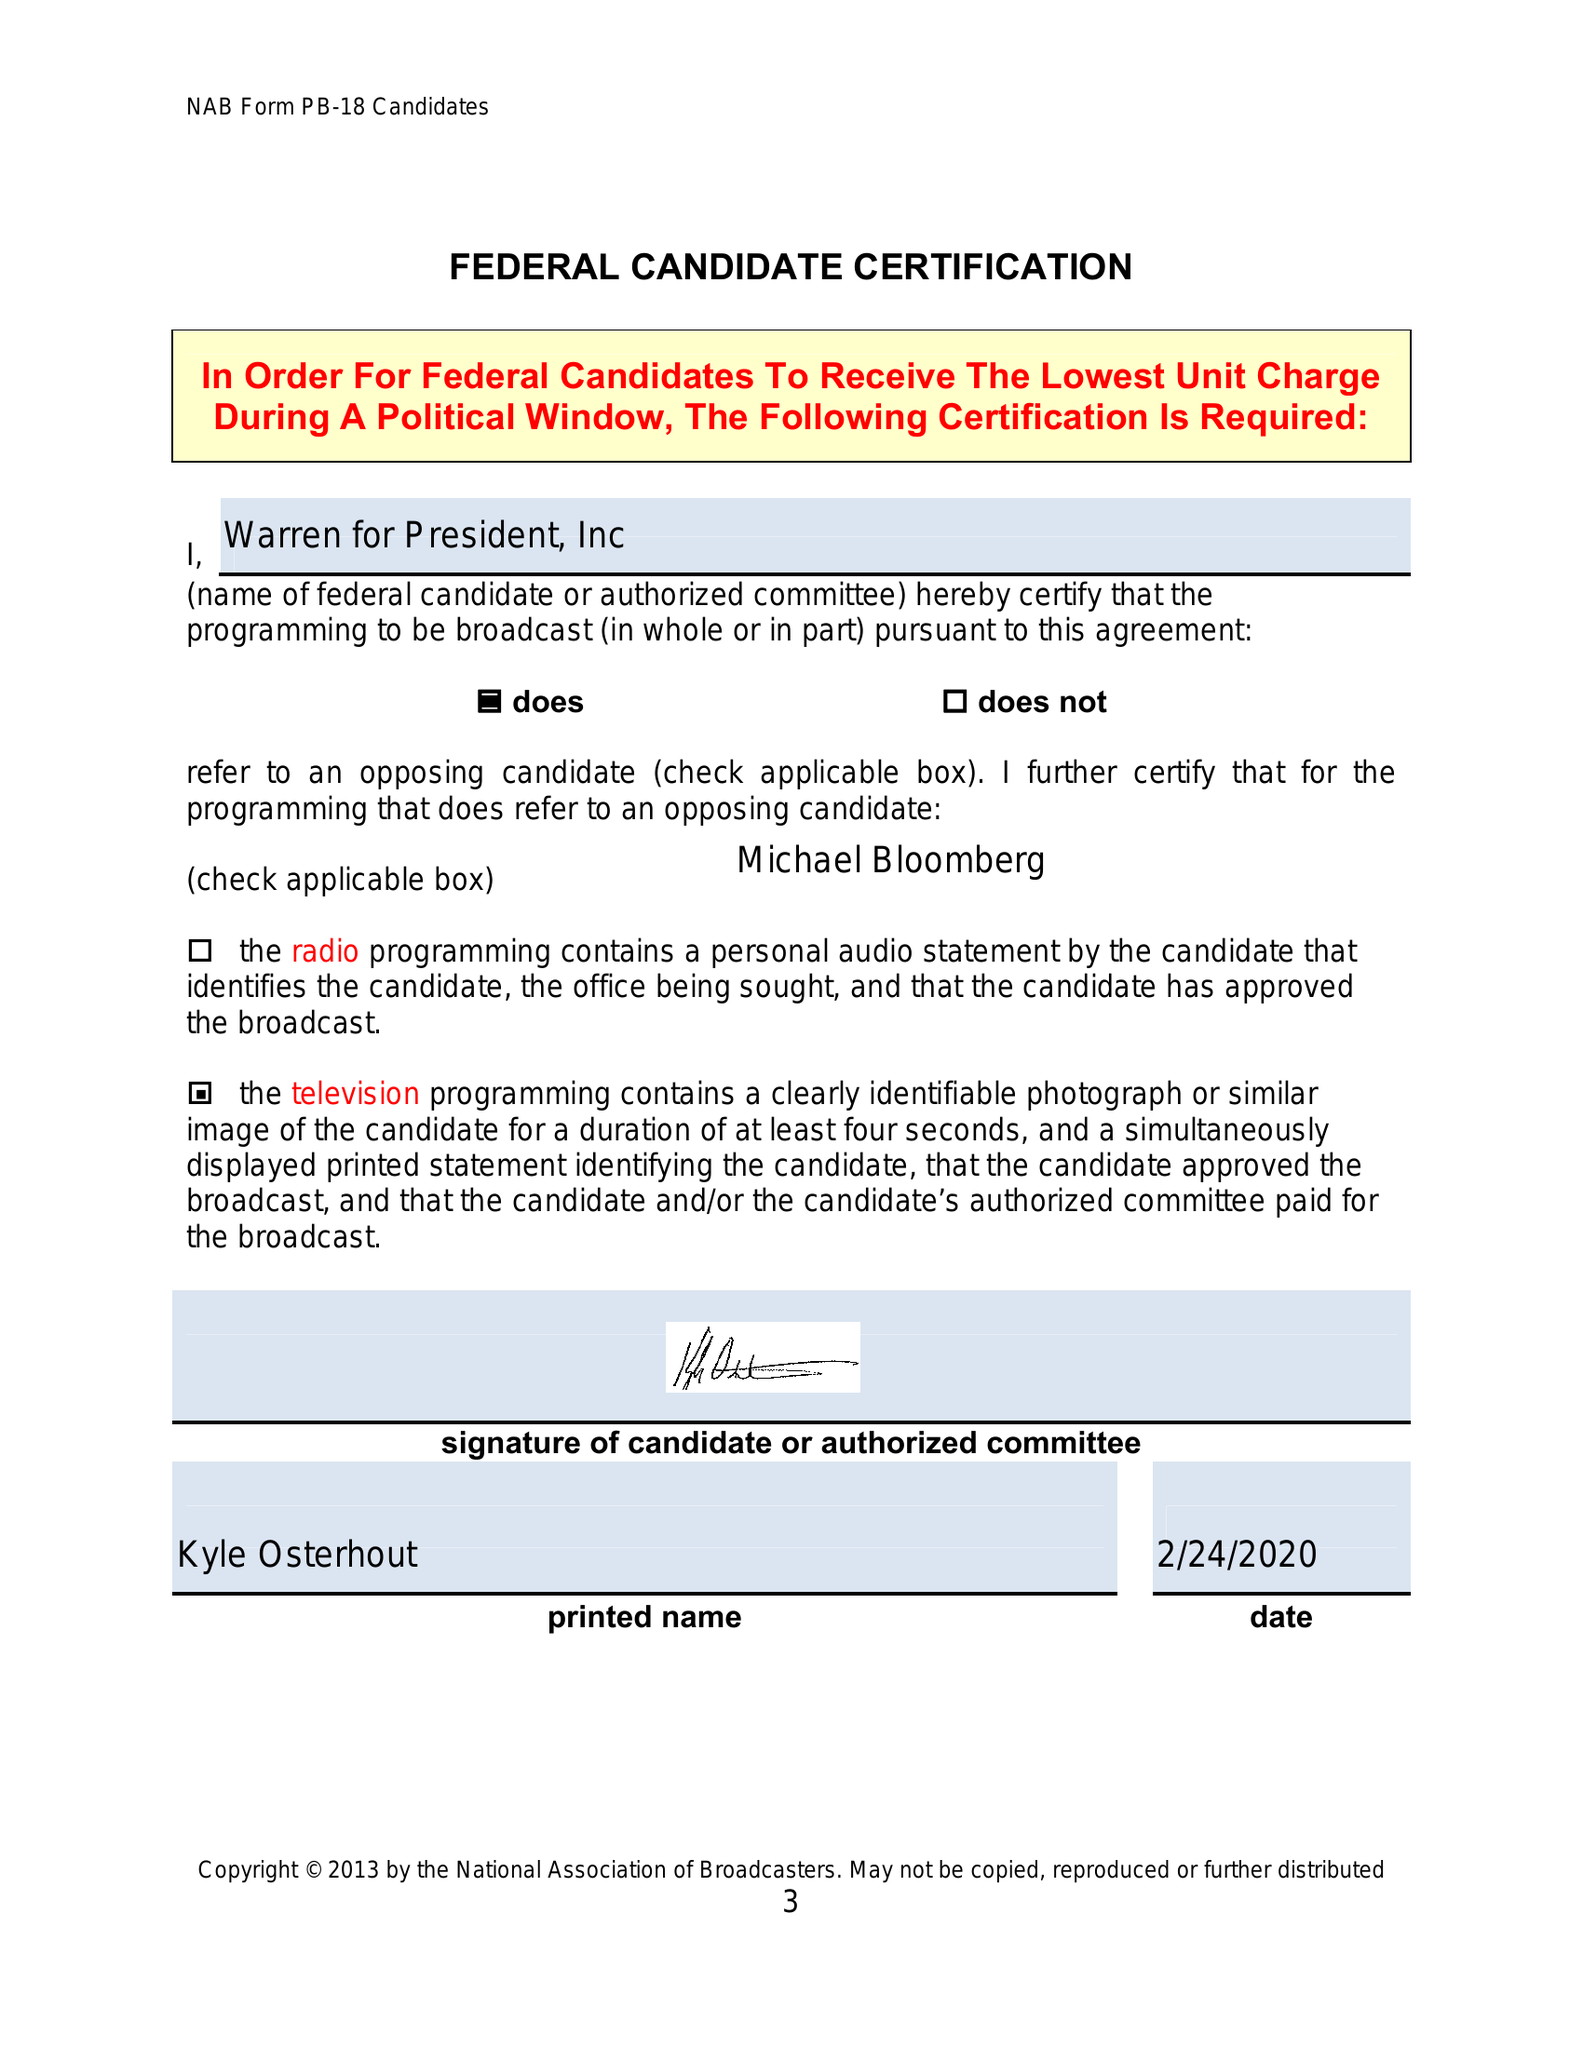What is the value for the contract_num?
Answer the question using a single word or phrase. None 